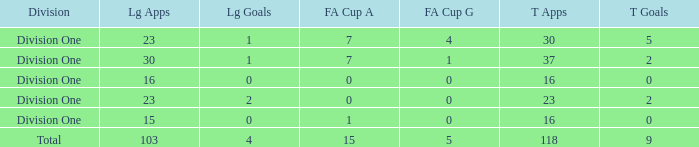It has fa cup goals larger than 0 and total goals of 0, what is the average total apps? None. 